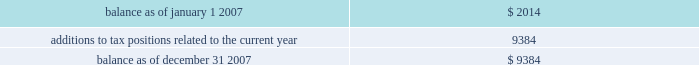Ventas , inc .
Notes to consolidated financial statements 2014 ( continued ) we have a combined nol carryforward of $ 66.5 million at december 31 , 2007 related to the trs entities and an nol carryforward reported by the reit of $ 88.6 million .
These amounts can be used to offset future taxable income ( and/or taxable income for prior years if audits of any prior year 2019s return determine that amounts are owed ) , if any .
The reit will be entitled to utilize nols and tax credit carryforwards only to the extent that reit taxable income exceeds our deduction for dividends paid .
The nol carryforwards begin to expire in 2024 with respect to the trs entities and in 2018 for the reit .
As a result of the uncertainties relating to the ultimate utilization of existing reit nols , no net deferred tax benefit has been ascribed to reit nol carryforwards as of december 31 , 2007 and 2006 .
The irs may challenge our entitlement to these tax attributes during its review of the tax returns for the previous tax years .
We believe we are entitled to these tax attributes , but we cannot assure you as to the outcome of these matters .
On january 1 , 2007 , we adopted fin 48 .
As a result of applying the provisions of fin 48 , we recognized no change in the liability for unrecognized tax benefits , and no adjustment in accumulated earnings as of january 1 , 2007 .
Our policy is to recognize interest and penalties related to unrecognized tax benefits in income tax expense .
The table summarizes the activity related to our unrecognized tax benefits ( in thousands ) : .
Included in the unrecognized tax benefits of $ 9.4 million at december 31 , 2007 was $ 9.4 million of tax benefits that , if recognized , would reduce our annual effective tax rate .
We accrued no potential penalties and interest related to the unrecognized tax benefits during 2007 , and in total , as of december 31 , 2007 , we have recorded no liability for potential penalties and interest .
We expect our unrecognized tax benefits to increase by $ 2.7 million during 2008 .
Note 13 2014commitments and contingencies assumption of certain operating liabilities and litigation as a result of the structure of the sunrise reit acquisition , we may be subject to various liabilities of sunrise reit arising out of the ownership or operation of the sunrise reit properties prior to the acquisition .
If the liabilities we have assumed are greater than expected , or if there are obligations relating to the sunrise reit properties of which we were not aware at the time of completion of the sunrise reit acquisition , such liabilities and/or obligations could have a material adverse effect on us .
In connection with our spin off of kindred in 1998 , kindred agreed , among other things , to assume all liabilities and to indemnify , defend and hold us harmless from and against certain losses , claims and litigation arising out of the ownership or operation of the healthcare operations or any of the assets transferred to kindred in the spin off , including without limitation all claims arising out of the third-party leases and third-party guarantees assigned to and assumed by kindred at the time of the spin off .
Under kindred 2019s plan of reorganization , kindred assumed and agreed to fulfill these obligations .
The total aggregate remaining minimum rental payments under the third-party leases was approximately $ 16.0 million as of december 31 , 2007 , and we believe that we had no material exposure under the third-party guarantees .
Similarly , in connection with provident 2019s acquisition of certain brookdale-related and alterra-related entities in 2005 and our subsequent acquisition of provident , brookdale and alterra agreed , among other things .
What is the anticipated growth rate of the unrecognized tax benefits in 2008? 
Rationale: the growth rate is the change divided by the original amount
Computations: (2.7 / 9.4)
Answer: 0.28723. 